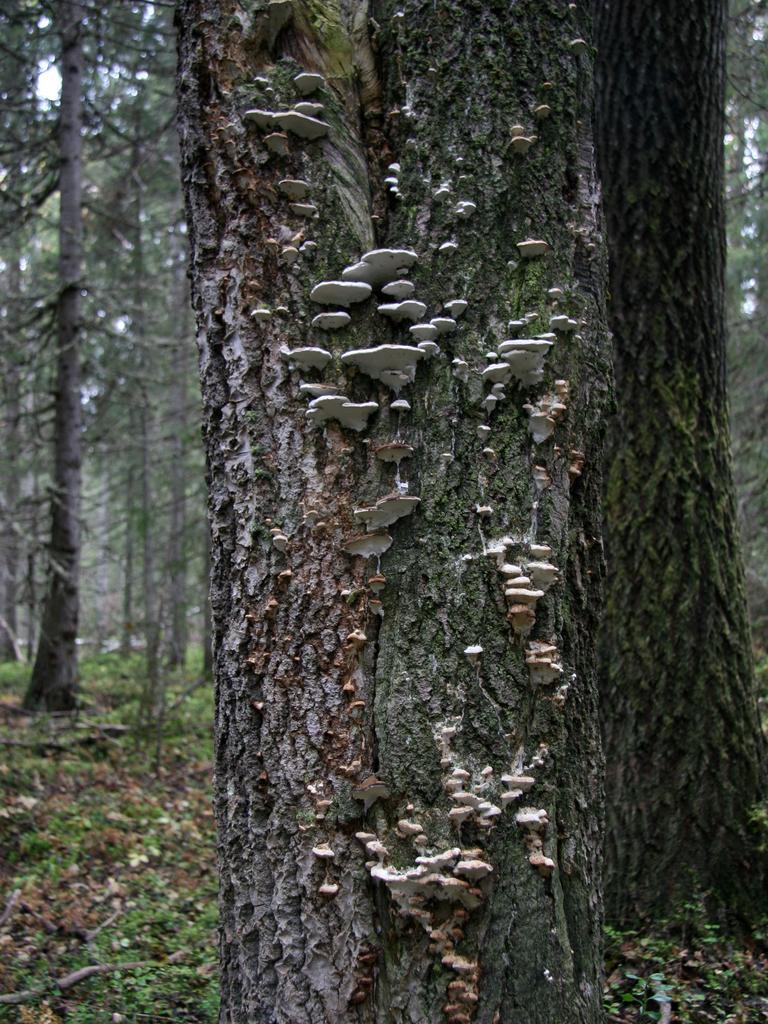Can you describe this image briefly? In the foreground of the image we can see bark of a tree. In the background, we can see a group of trees, grass and the sky. 